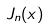<formula> <loc_0><loc_0><loc_500><loc_500>J _ { n } ( x )</formula> 